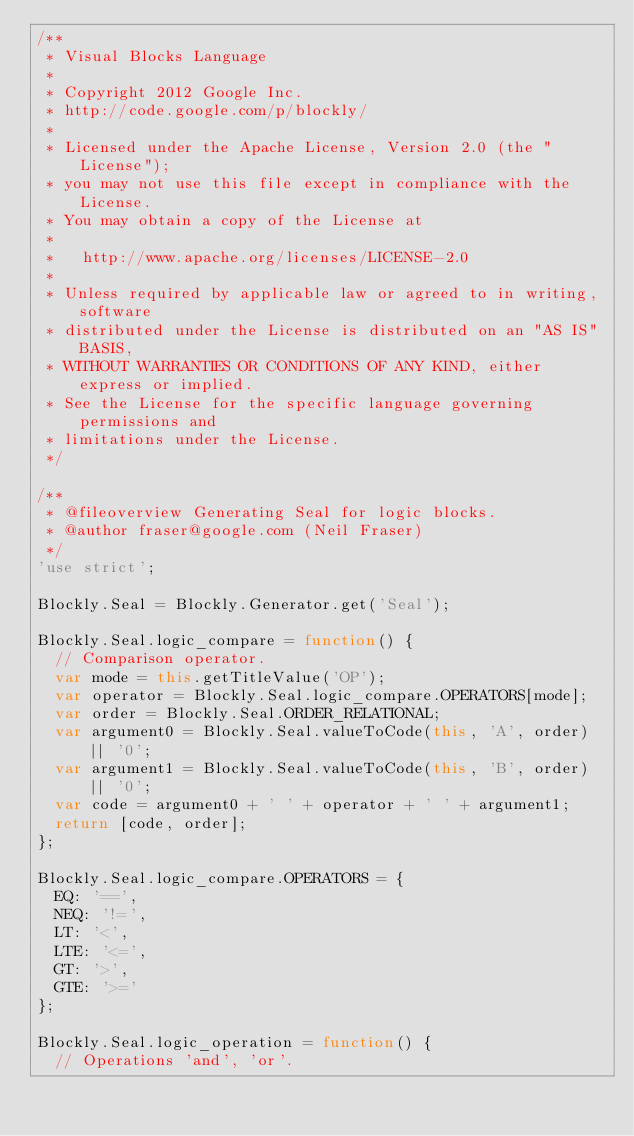<code> <loc_0><loc_0><loc_500><loc_500><_JavaScript_>/**
 * Visual Blocks Language
 *
 * Copyright 2012 Google Inc.
 * http://code.google.com/p/blockly/
 *
 * Licensed under the Apache License, Version 2.0 (the "License");
 * you may not use this file except in compliance with the License.
 * You may obtain a copy of the License at
 *
 *   http://www.apache.org/licenses/LICENSE-2.0
 *
 * Unless required by applicable law or agreed to in writing, software
 * distributed under the License is distributed on an "AS IS" BASIS,
 * WITHOUT WARRANTIES OR CONDITIONS OF ANY KIND, either express or implied.
 * See the License for the specific language governing permissions and
 * limitations under the License.
 */

/**
 * @fileoverview Generating Seal for logic blocks.
 * @author fraser@google.com (Neil Fraser)
 */
'use strict';

Blockly.Seal = Blockly.Generator.get('Seal');

Blockly.Seal.logic_compare = function() {
  // Comparison operator.
  var mode = this.getTitleValue('OP');
  var operator = Blockly.Seal.logic_compare.OPERATORS[mode];
  var order = Blockly.Seal.ORDER_RELATIONAL;
  var argument0 = Blockly.Seal.valueToCode(this, 'A', order) || '0';
  var argument1 = Blockly.Seal.valueToCode(this, 'B', order) || '0';
  var code = argument0 + ' ' + operator + ' ' + argument1;
  return [code, order];
};

Blockly.Seal.logic_compare.OPERATORS = {
  EQ: '==',
  NEQ: '!=',
  LT: '<',
  LTE: '<=',
  GT: '>',
  GTE: '>='
};

Blockly.Seal.logic_operation = function() {
  // Operations 'and', 'or'.</code> 